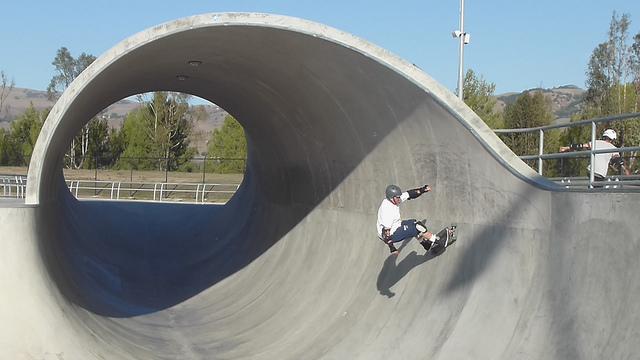What color is the helmet of the skater in the front of the picture?
Write a very short answer. Gray. How many people are in the picture?
Keep it brief. 2. How many skateboard are there?
Write a very short answer. 1. 